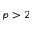Convert formula to latex. <formula><loc_0><loc_0><loc_500><loc_500>p > 2</formula> 